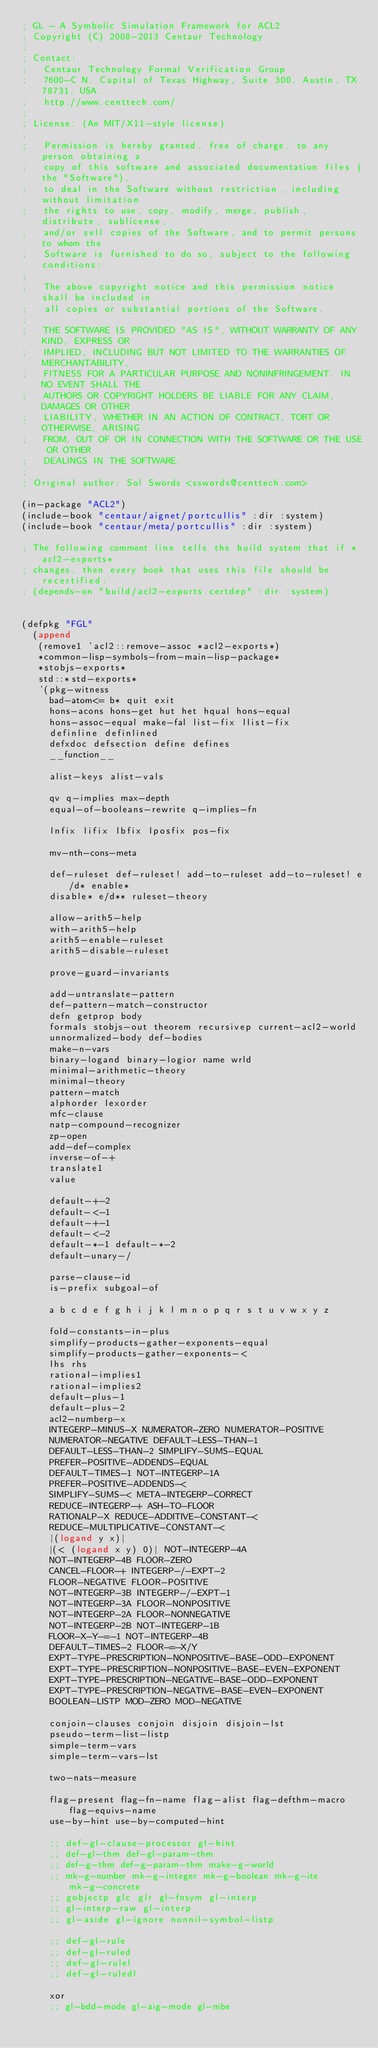Convert code to text. <code><loc_0><loc_0><loc_500><loc_500><_Lisp_>; GL - A Symbolic Simulation Framework for ACL2
; Copyright (C) 2008-2013 Centaur Technology
;
; Contact:
;   Centaur Technology Formal Verification Group
;   7600-C N. Capital of Texas Highway, Suite 300, Austin, TX 78731, USA.
;   http://www.centtech.com/
;
; License: (An MIT/X11-style license)
;
;   Permission is hereby granted, free of charge, to any person obtaining a
;   copy of this software and associated documentation files (the "Software"),
;   to deal in the Software without restriction, including without limitation
;   the rights to use, copy, modify, merge, publish, distribute, sublicense,
;   and/or sell copies of the Software, and to permit persons to whom the
;   Software is furnished to do so, subject to the following conditions:
;
;   The above copyright notice and this permission notice shall be included in
;   all copies or substantial portions of the Software.
;
;   THE SOFTWARE IS PROVIDED "AS IS", WITHOUT WARRANTY OF ANY KIND, EXPRESS OR
;   IMPLIED, INCLUDING BUT NOT LIMITED TO THE WARRANTIES OF MERCHANTABILITY,
;   FITNESS FOR A PARTICULAR PURPOSE AND NONINFRINGEMENT. IN NO EVENT SHALL THE
;   AUTHORS OR COPYRIGHT HOLDERS BE LIABLE FOR ANY CLAIM, DAMAGES OR OTHER
;   LIABILITY, WHETHER IN AN ACTION OF CONTRACT, TORT OR OTHERWISE, ARISING
;   FROM, OUT OF OR IN CONNECTION WITH THE SOFTWARE OR THE USE OR OTHER
;   DEALINGS IN THE SOFTWARE.
;
; Original author: Sol Swords <sswords@centtech.com>

(in-package "ACL2")
(include-book "centaur/aignet/portcullis" :dir :system)
(include-book "centaur/meta/portcullis" :dir :system)

; The following comment line tells the build system that if *acl2-exports*
; changes, then every book that uses this file should be recertified:
; (depends-on "build/acl2-exports.certdep" :dir :system)


(defpkg "FGL"
  (append
   (remove1 'acl2::remove-assoc *acl2-exports*)
   *common-lisp-symbols-from-main-lisp-package*
   *stobjs-exports*
   std::*std-exports*
   '(pkg-witness
     bad-atom<= b* quit exit
     hons-acons hons-get hut het hqual hons-equal
     hons-assoc-equal make-fal list-fix llist-fix
     definline definlined
     defxdoc defsection define defines
     __function__

     alist-keys alist-vals

     qv q-implies max-depth
     equal-of-booleans-rewrite q-implies-fn

     lnfix lifix lbfix lposfix pos-fix

     mv-nth-cons-meta

     def-ruleset def-ruleset! add-to-ruleset add-to-ruleset! e/d* enable*
     disable* e/d** ruleset-theory

     allow-arith5-help
     with-arith5-help
     arith5-enable-ruleset
     arith5-disable-ruleset

     prove-guard-invariants

     add-untranslate-pattern
     def-pattern-match-constructor
     defn getprop body
     formals stobjs-out theorem recursivep current-acl2-world
     unnormalized-body def-bodies
     make-n-vars
     binary-logand binary-logior name wrld
     minimal-arithmetic-theory
     minimal-theory
     pattern-match
     alphorder lexorder
     mfc-clause
     natp-compound-recognizer
     zp-open
     add-def-complex
     inverse-of-+
     translate1
     value

     default-+-2
     default-<-1
     default-+-1
     default-<-2
     default-*-1 default-*-2
     default-unary-/

     parse-clause-id
     is-prefix subgoal-of

     a b c d e f g h i j k l m n o p q r s t u v w x y z

     fold-constants-in-plus
     simplify-products-gather-exponents-equal
     simplify-products-gather-exponents-<
     lhs rhs
     rational-implies1
     rational-implies2
     default-plus-1
     default-plus-2
     acl2-numberp-x
     INTEGERP-MINUS-X NUMERATOR-ZERO NUMERATOR-POSITIVE
     NUMERATOR-NEGATIVE DEFAULT-LESS-THAN-1
     DEFAULT-LESS-THAN-2 SIMPLIFY-SUMS-EQUAL
     PREFER-POSITIVE-ADDENDS-EQUAL
     DEFAULT-TIMES-1 NOT-INTEGERP-1A
     PREFER-POSITIVE-ADDENDS-<
     SIMPLIFY-SUMS-< META-INTEGERP-CORRECT
     REDUCE-INTEGERP-+ ASH-TO-FLOOR
     RATIONALP-X REDUCE-ADDITIVE-CONSTANT-<
     REDUCE-MULTIPLICATIVE-CONSTANT-<
     |(logand y x)|
     |(< (logand x y) 0)| NOT-INTEGERP-4A
     NOT-INTEGERP-4B FLOOR-ZERO
     CANCEL-FLOOR-+ INTEGERP-/-EXPT-2
     FLOOR-NEGATIVE FLOOR-POSITIVE
     NOT-INTEGERP-3B INTEGERP-/-EXPT-1
     NOT-INTEGERP-3A FLOOR-NONPOSITIVE
     NOT-INTEGERP-2A FLOOR-NONNEGATIVE
     NOT-INTEGERP-2B NOT-INTEGERP-1B
     FLOOR-X-Y-=-1 NOT-INTEGERP-4B
     DEFAULT-TIMES-2 FLOOR-=-X/Y
     EXPT-TYPE-PRESCRIPTION-NONPOSITIVE-BASE-ODD-EXPONENT
     EXPT-TYPE-PRESCRIPTION-NONPOSITIVE-BASE-EVEN-EXPONENT
     EXPT-TYPE-PRESCRIPTION-NEGATIVE-BASE-ODD-EXPONENT
     EXPT-TYPE-PRESCRIPTION-NEGATIVE-BASE-EVEN-EXPONENT
     BOOLEAN-LISTP MOD-ZERO MOD-NEGATIVE

     conjoin-clauses conjoin disjoin disjoin-lst
     pseudo-term-list-listp
     simple-term-vars
     simple-term-vars-lst

     two-nats-measure

     flag-present flag-fn-name flag-alist flag-defthm-macro flag-equivs-name
     use-by-hint use-by-computed-hint

     ;; def-gl-clause-processor gl-hint
     ;; def-gl-thm def-gl-param-thm
     ;; def-g-thm def-g-param-thm make-g-world
     ;; mk-g-number mk-g-integer mk-g-boolean mk-g-ite mk-g-concrete
     ;; gobjectp glc glr gl-fnsym gl-interp
     ;; gl-interp-raw gl-interp
     ;; gl-aside gl-ignore nonnil-symbol-listp

     ;; def-gl-rule
     ;; def-gl-ruled
     ;; def-gl-rulel
     ;; def-gl-ruledl

     xor
     ;; gl-bdd-mode gl-aig-mode gl-mbe
</code> 